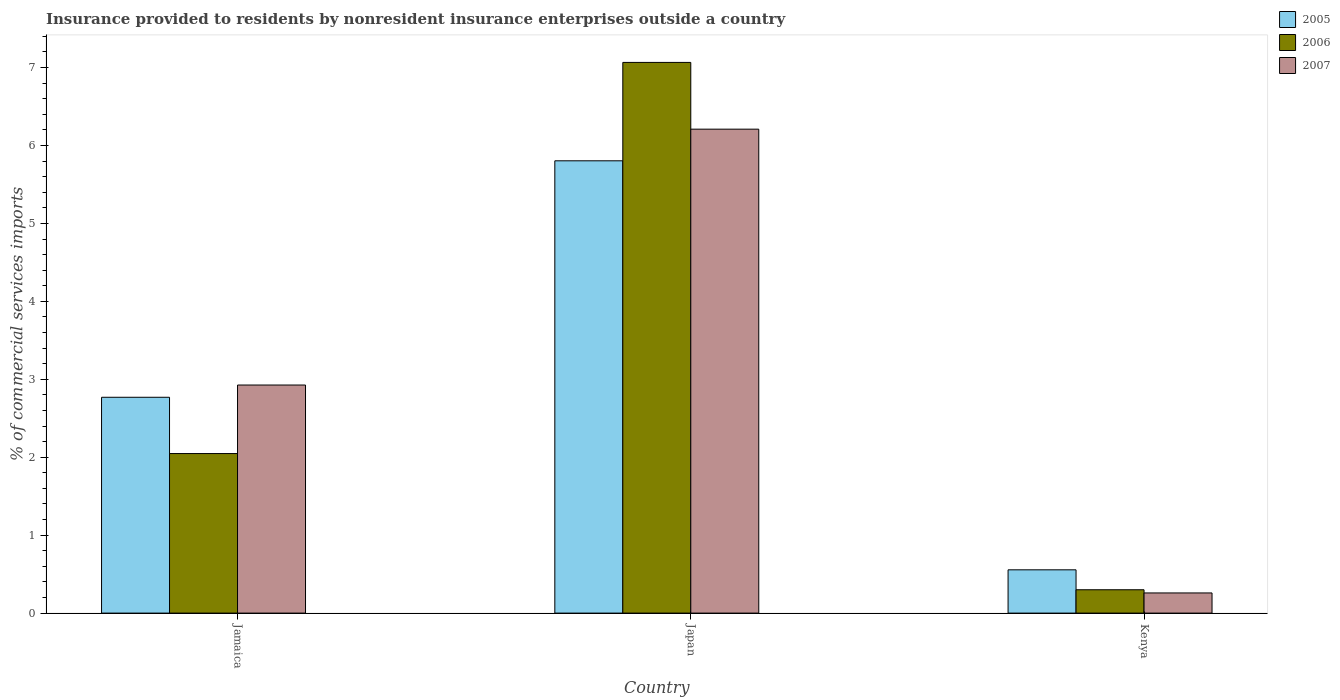How many groups of bars are there?
Your answer should be compact. 3. Are the number of bars on each tick of the X-axis equal?
Your response must be concise. Yes. How many bars are there on the 3rd tick from the left?
Offer a terse response. 3. How many bars are there on the 2nd tick from the right?
Your answer should be very brief. 3. What is the label of the 2nd group of bars from the left?
Your response must be concise. Japan. What is the Insurance provided to residents in 2005 in Jamaica?
Provide a succinct answer. 2.77. Across all countries, what is the maximum Insurance provided to residents in 2007?
Provide a succinct answer. 6.21. Across all countries, what is the minimum Insurance provided to residents in 2006?
Make the answer very short. 0.3. In which country was the Insurance provided to residents in 2006 minimum?
Your answer should be very brief. Kenya. What is the total Insurance provided to residents in 2006 in the graph?
Keep it short and to the point. 9.41. What is the difference between the Insurance provided to residents in 2007 in Jamaica and that in Japan?
Make the answer very short. -3.28. What is the difference between the Insurance provided to residents in 2007 in Jamaica and the Insurance provided to residents in 2006 in Kenya?
Give a very brief answer. 2.63. What is the average Insurance provided to residents in 2007 per country?
Offer a very short reply. 3.13. What is the difference between the Insurance provided to residents of/in 2005 and Insurance provided to residents of/in 2007 in Kenya?
Keep it short and to the point. 0.3. In how many countries, is the Insurance provided to residents in 2007 greater than 4 %?
Your answer should be very brief. 1. What is the ratio of the Insurance provided to residents in 2007 in Japan to that in Kenya?
Ensure brevity in your answer.  24.01. What is the difference between the highest and the second highest Insurance provided to residents in 2006?
Give a very brief answer. -1.75. What is the difference between the highest and the lowest Insurance provided to residents in 2006?
Provide a succinct answer. 6.77. In how many countries, is the Insurance provided to residents in 2005 greater than the average Insurance provided to residents in 2005 taken over all countries?
Offer a very short reply. 1. What does the 1st bar from the left in Jamaica represents?
Give a very brief answer. 2005. What does the 1st bar from the right in Kenya represents?
Ensure brevity in your answer.  2007. Is it the case that in every country, the sum of the Insurance provided to residents in 2006 and Insurance provided to residents in 2005 is greater than the Insurance provided to residents in 2007?
Offer a very short reply. Yes. How many bars are there?
Your answer should be compact. 9. Are all the bars in the graph horizontal?
Ensure brevity in your answer.  No. Does the graph contain any zero values?
Provide a succinct answer. No. Does the graph contain grids?
Make the answer very short. No. What is the title of the graph?
Offer a terse response. Insurance provided to residents by nonresident insurance enterprises outside a country. Does "1975" appear as one of the legend labels in the graph?
Provide a short and direct response. No. What is the label or title of the X-axis?
Your response must be concise. Country. What is the label or title of the Y-axis?
Ensure brevity in your answer.  % of commercial services imports. What is the % of commercial services imports of 2005 in Jamaica?
Keep it short and to the point. 2.77. What is the % of commercial services imports of 2006 in Jamaica?
Make the answer very short. 2.05. What is the % of commercial services imports of 2007 in Jamaica?
Your answer should be compact. 2.93. What is the % of commercial services imports in 2005 in Japan?
Offer a very short reply. 5.8. What is the % of commercial services imports of 2006 in Japan?
Your answer should be compact. 7.07. What is the % of commercial services imports in 2007 in Japan?
Keep it short and to the point. 6.21. What is the % of commercial services imports in 2005 in Kenya?
Make the answer very short. 0.56. What is the % of commercial services imports of 2006 in Kenya?
Offer a very short reply. 0.3. What is the % of commercial services imports of 2007 in Kenya?
Offer a very short reply. 0.26. Across all countries, what is the maximum % of commercial services imports in 2005?
Your response must be concise. 5.8. Across all countries, what is the maximum % of commercial services imports in 2006?
Provide a short and direct response. 7.07. Across all countries, what is the maximum % of commercial services imports in 2007?
Your answer should be compact. 6.21. Across all countries, what is the minimum % of commercial services imports in 2005?
Offer a very short reply. 0.56. Across all countries, what is the minimum % of commercial services imports of 2006?
Offer a very short reply. 0.3. Across all countries, what is the minimum % of commercial services imports of 2007?
Your response must be concise. 0.26. What is the total % of commercial services imports of 2005 in the graph?
Offer a very short reply. 9.13. What is the total % of commercial services imports in 2006 in the graph?
Your answer should be compact. 9.41. What is the total % of commercial services imports in 2007 in the graph?
Your answer should be compact. 9.4. What is the difference between the % of commercial services imports in 2005 in Jamaica and that in Japan?
Keep it short and to the point. -3.03. What is the difference between the % of commercial services imports of 2006 in Jamaica and that in Japan?
Offer a terse response. -5.02. What is the difference between the % of commercial services imports of 2007 in Jamaica and that in Japan?
Offer a very short reply. -3.28. What is the difference between the % of commercial services imports in 2005 in Jamaica and that in Kenya?
Your answer should be compact. 2.21. What is the difference between the % of commercial services imports in 2006 in Jamaica and that in Kenya?
Offer a very short reply. 1.75. What is the difference between the % of commercial services imports of 2007 in Jamaica and that in Kenya?
Keep it short and to the point. 2.67. What is the difference between the % of commercial services imports of 2005 in Japan and that in Kenya?
Make the answer very short. 5.25. What is the difference between the % of commercial services imports of 2006 in Japan and that in Kenya?
Provide a succinct answer. 6.77. What is the difference between the % of commercial services imports in 2007 in Japan and that in Kenya?
Offer a terse response. 5.95. What is the difference between the % of commercial services imports of 2005 in Jamaica and the % of commercial services imports of 2006 in Japan?
Provide a succinct answer. -4.3. What is the difference between the % of commercial services imports of 2005 in Jamaica and the % of commercial services imports of 2007 in Japan?
Your response must be concise. -3.44. What is the difference between the % of commercial services imports in 2006 in Jamaica and the % of commercial services imports in 2007 in Japan?
Ensure brevity in your answer.  -4.16. What is the difference between the % of commercial services imports of 2005 in Jamaica and the % of commercial services imports of 2006 in Kenya?
Offer a terse response. 2.47. What is the difference between the % of commercial services imports in 2005 in Jamaica and the % of commercial services imports in 2007 in Kenya?
Offer a terse response. 2.51. What is the difference between the % of commercial services imports of 2006 in Jamaica and the % of commercial services imports of 2007 in Kenya?
Provide a short and direct response. 1.79. What is the difference between the % of commercial services imports of 2005 in Japan and the % of commercial services imports of 2006 in Kenya?
Provide a succinct answer. 5.5. What is the difference between the % of commercial services imports of 2005 in Japan and the % of commercial services imports of 2007 in Kenya?
Your response must be concise. 5.54. What is the difference between the % of commercial services imports in 2006 in Japan and the % of commercial services imports in 2007 in Kenya?
Keep it short and to the point. 6.81. What is the average % of commercial services imports in 2005 per country?
Give a very brief answer. 3.04. What is the average % of commercial services imports of 2006 per country?
Offer a terse response. 3.14. What is the average % of commercial services imports in 2007 per country?
Provide a succinct answer. 3.13. What is the difference between the % of commercial services imports of 2005 and % of commercial services imports of 2006 in Jamaica?
Give a very brief answer. 0.72. What is the difference between the % of commercial services imports in 2005 and % of commercial services imports in 2007 in Jamaica?
Your answer should be compact. -0.16. What is the difference between the % of commercial services imports of 2006 and % of commercial services imports of 2007 in Jamaica?
Offer a terse response. -0.88. What is the difference between the % of commercial services imports of 2005 and % of commercial services imports of 2006 in Japan?
Make the answer very short. -1.26. What is the difference between the % of commercial services imports of 2005 and % of commercial services imports of 2007 in Japan?
Your response must be concise. -0.41. What is the difference between the % of commercial services imports of 2006 and % of commercial services imports of 2007 in Japan?
Make the answer very short. 0.86. What is the difference between the % of commercial services imports of 2005 and % of commercial services imports of 2006 in Kenya?
Ensure brevity in your answer.  0.26. What is the difference between the % of commercial services imports of 2005 and % of commercial services imports of 2007 in Kenya?
Provide a short and direct response. 0.3. What is the difference between the % of commercial services imports in 2006 and % of commercial services imports in 2007 in Kenya?
Offer a terse response. 0.04. What is the ratio of the % of commercial services imports in 2005 in Jamaica to that in Japan?
Your response must be concise. 0.48. What is the ratio of the % of commercial services imports in 2006 in Jamaica to that in Japan?
Provide a succinct answer. 0.29. What is the ratio of the % of commercial services imports of 2007 in Jamaica to that in Japan?
Make the answer very short. 0.47. What is the ratio of the % of commercial services imports of 2005 in Jamaica to that in Kenya?
Your response must be concise. 4.99. What is the ratio of the % of commercial services imports of 2006 in Jamaica to that in Kenya?
Provide a short and direct response. 6.84. What is the ratio of the % of commercial services imports in 2007 in Jamaica to that in Kenya?
Give a very brief answer. 11.32. What is the ratio of the % of commercial services imports in 2005 in Japan to that in Kenya?
Ensure brevity in your answer.  10.45. What is the ratio of the % of commercial services imports in 2006 in Japan to that in Kenya?
Your answer should be very brief. 23.59. What is the ratio of the % of commercial services imports in 2007 in Japan to that in Kenya?
Your response must be concise. 24.01. What is the difference between the highest and the second highest % of commercial services imports in 2005?
Make the answer very short. 3.03. What is the difference between the highest and the second highest % of commercial services imports of 2006?
Offer a very short reply. 5.02. What is the difference between the highest and the second highest % of commercial services imports in 2007?
Keep it short and to the point. 3.28. What is the difference between the highest and the lowest % of commercial services imports of 2005?
Your answer should be compact. 5.25. What is the difference between the highest and the lowest % of commercial services imports in 2006?
Your response must be concise. 6.77. What is the difference between the highest and the lowest % of commercial services imports in 2007?
Your answer should be compact. 5.95. 